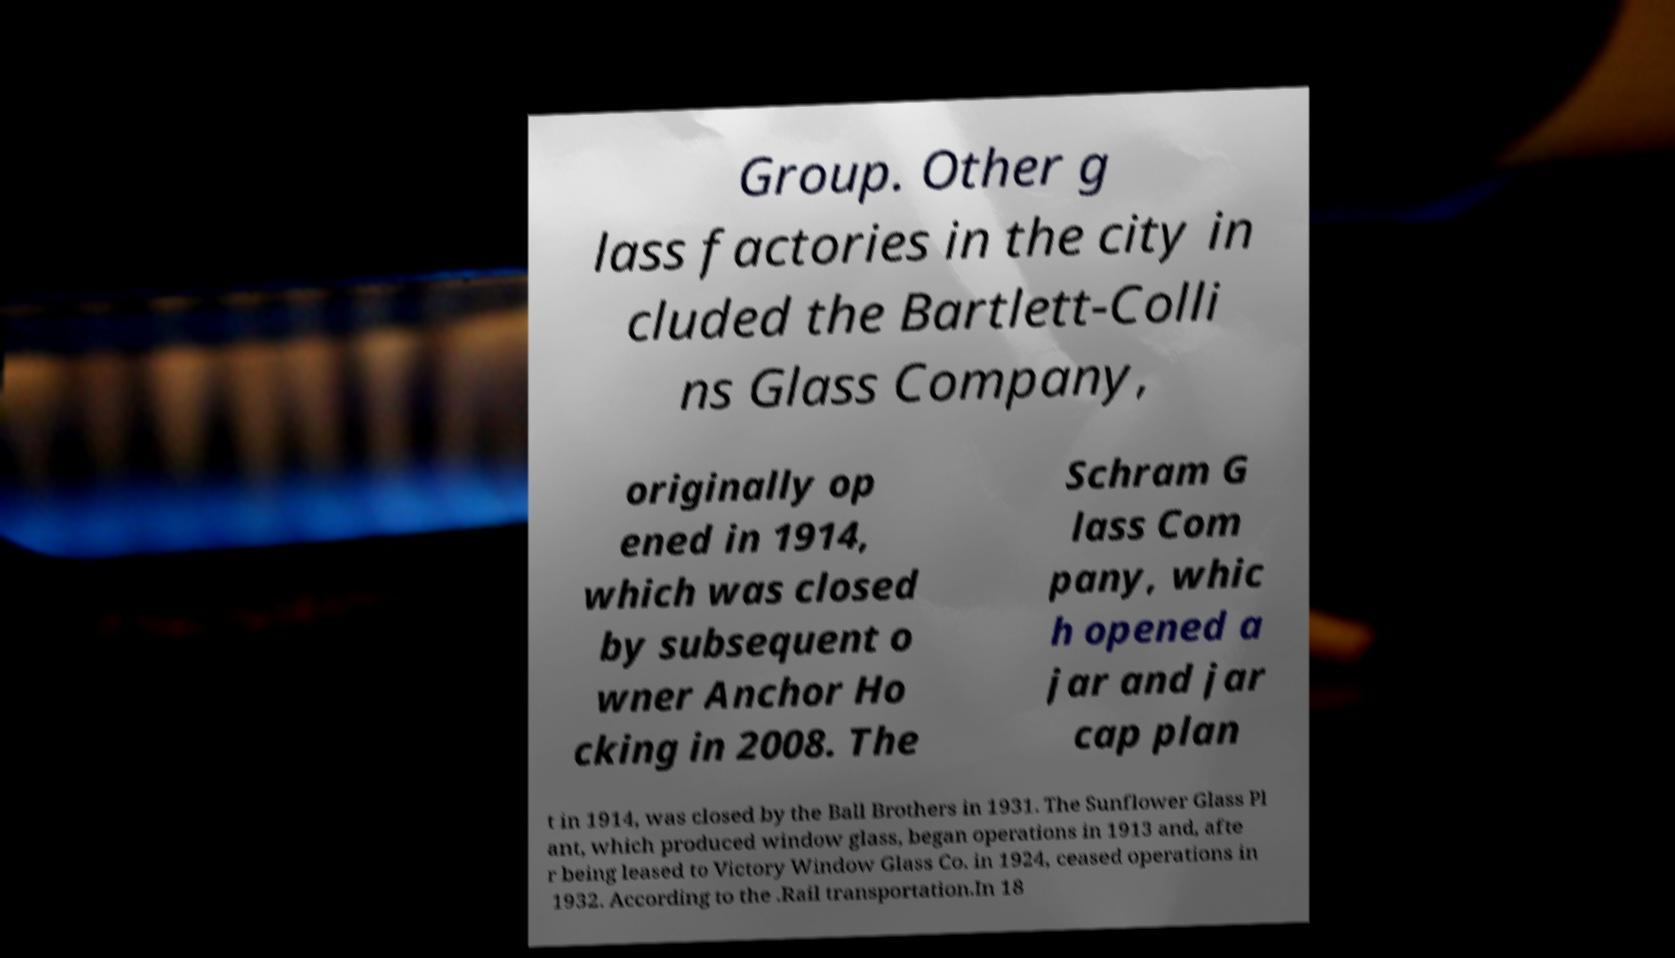Can you accurately transcribe the text from the provided image for me? Group. Other g lass factories in the city in cluded the Bartlett-Colli ns Glass Company, originally op ened in 1914, which was closed by subsequent o wner Anchor Ho cking in 2008. The Schram G lass Com pany, whic h opened a jar and jar cap plan t in 1914, was closed by the Ball Brothers in 1931. The Sunflower Glass Pl ant, which produced window glass, began operations in 1913 and, afte r being leased to Victory Window Glass Co. in 1924, ceased operations in 1932. According to the .Rail transportation.In 18 